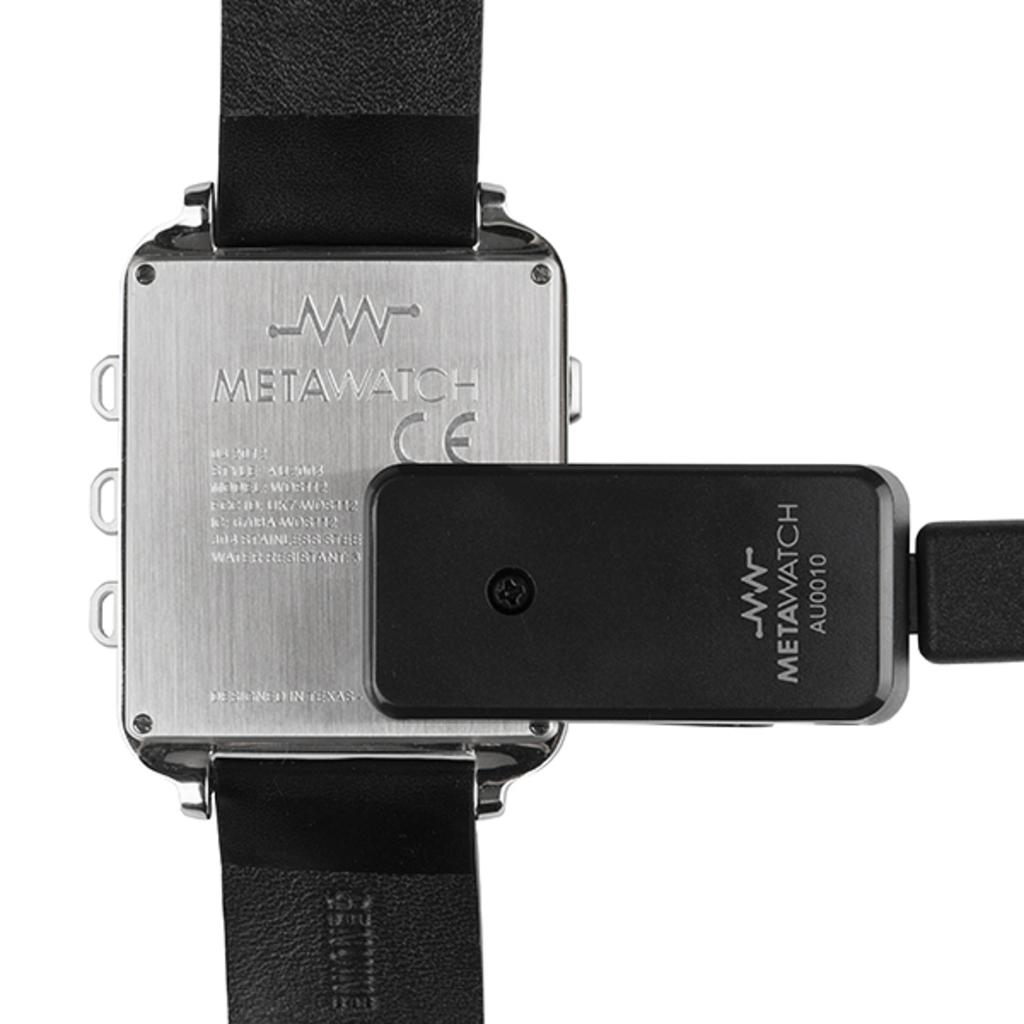Provide a one-sentence caption for the provided image. The back of a a Metawatch wrist watch attached with black straps. 